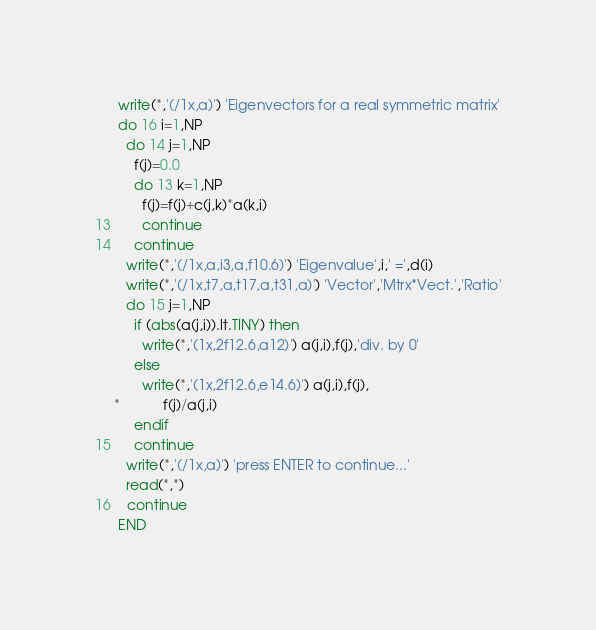<code> <loc_0><loc_0><loc_500><loc_500><_FORTRAN_>      write(*,'(/1x,a)') 'Eigenvectors for a real symmetric matrix'
      do 16 i=1,NP
        do 14 j=1,NP
          f(j)=0.0
          do 13 k=1,NP
            f(j)=f(j)+c(j,k)*a(k,i)
13        continue
14      continue
        write(*,'(/1x,a,i3,a,f10.6)') 'Eigenvalue',i,' =',d(i)
        write(*,'(/1x,t7,a,t17,a,t31,a)') 'Vector','Mtrx*Vect.','Ratio'
        do 15 j=1,NP
          if (abs(a(j,i)).lt.TINY) then
            write(*,'(1x,2f12.6,a12)') a(j,i),f(j),'div. by 0'
          else
            write(*,'(1x,2f12.6,e14.6)') a(j,i),f(j),
     *           f(j)/a(j,i)
          endif
15      continue
        write(*,'(/1x,a)') 'press ENTER to continue...'
        read(*,*)
16    continue
      END
</code> 